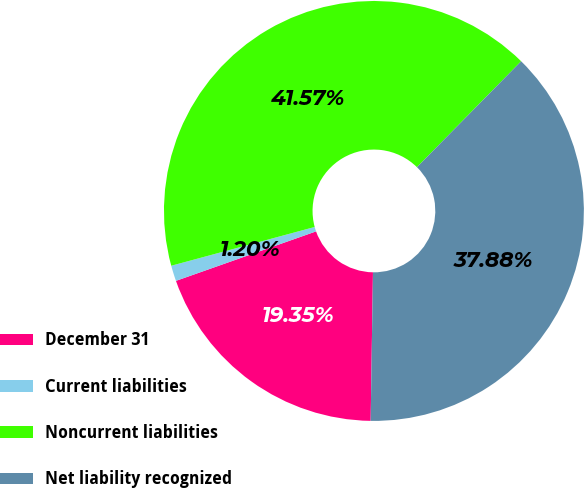<chart> <loc_0><loc_0><loc_500><loc_500><pie_chart><fcel>December 31<fcel>Current liabilities<fcel>Noncurrent liabilities<fcel>Net liability recognized<nl><fcel>19.35%<fcel>1.2%<fcel>41.57%<fcel>37.88%<nl></chart> 